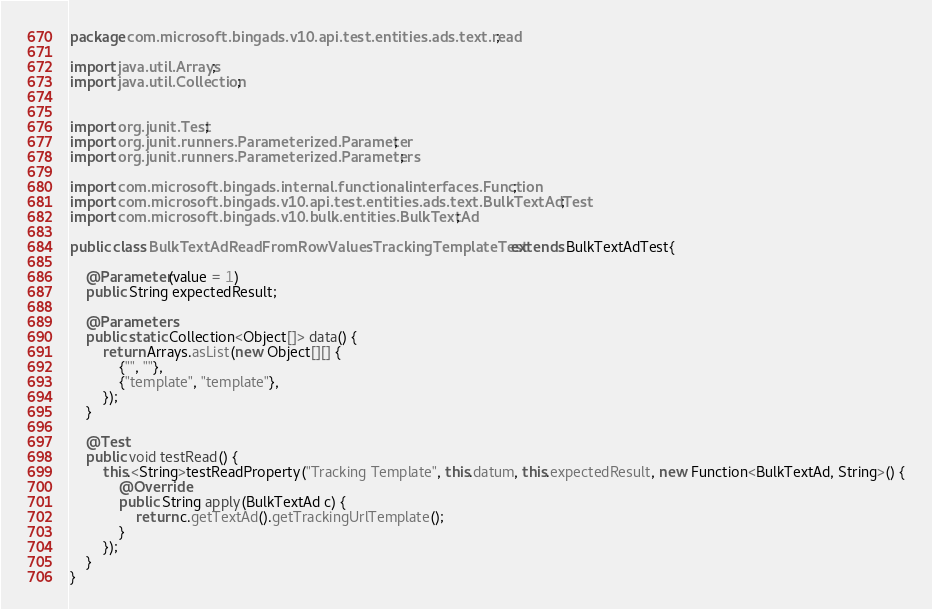Convert code to text. <code><loc_0><loc_0><loc_500><loc_500><_Java_>package com.microsoft.bingads.v10.api.test.entities.ads.text.read;

import java.util.Arrays;
import java.util.Collection;


import org.junit.Test;
import org.junit.runners.Parameterized.Parameter;
import org.junit.runners.Parameterized.Parameters;

import com.microsoft.bingads.internal.functionalinterfaces.Function;
import com.microsoft.bingads.v10.api.test.entities.ads.text.BulkTextAdTest;
import com.microsoft.bingads.v10.bulk.entities.BulkTextAd;

public class BulkTextAdReadFromRowValuesTrackingTemplateTest extends BulkTextAdTest{

	@Parameter(value = 1)
	public String expectedResult;
	
	@Parameters
	public static Collection<Object[]> data() {
		return Arrays.asList(new Object[][] {
			{"", ""},
			{"template", "template"},
		});
	}
	
	@Test
	public void testRead() {
		this.<String>testReadProperty("Tracking Template", this.datum, this.expectedResult, new Function<BulkTextAd, String>() {
			@Override
			public String apply(BulkTextAd c) {
				return c.getTextAd().getTrackingUrlTemplate();
			}
		});
	}
}
</code> 